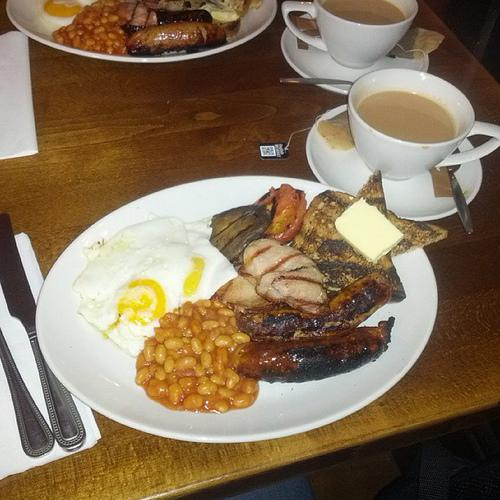Question: what are mainly featured?
Choices:
A. Crackers.
B. Cheese.
C. Wine.
D. Food.
Answer with the letter. Answer: D Question: what is in the mug?
Choices:
A. Coffee.
B. Broth.
C. Tea.
D. Hot milk.
Answer with the letter. Answer: C 